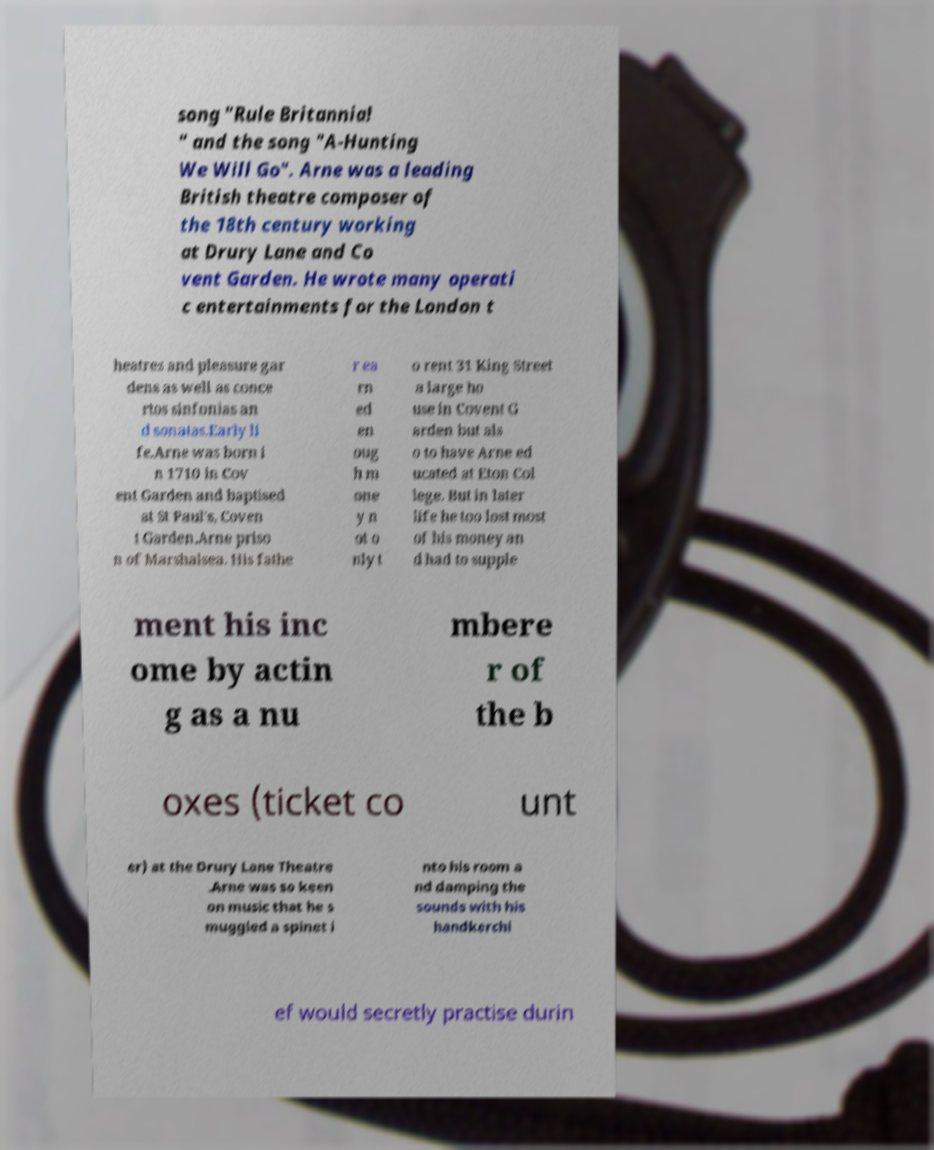Please read and relay the text visible in this image. What does it say? song "Rule Britannia! " and the song "A-Hunting We Will Go". Arne was a leading British theatre composer of the 18th century working at Drury Lane and Co vent Garden. He wrote many operati c entertainments for the London t heatres and pleasure gar dens as well as conce rtos sinfonias an d sonatas.Early li fe.Arne was born i n 1710 in Cov ent Garden and baptised at St Paul's, Coven t Garden.Arne priso n of Marshalsea. His fathe r ea rn ed en oug h m one y n ot o nly t o rent 31 King Street a large ho use in Covent G arden but als o to have Arne ed ucated at Eton Col lege. But in later life he too lost most of his money an d had to supple ment his inc ome by actin g as a nu mbere r of the b oxes (ticket co unt er) at the Drury Lane Theatre .Arne was so keen on music that he s muggled a spinet i nto his room a nd damping the sounds with his handkerchi ef would secretly practise durin 